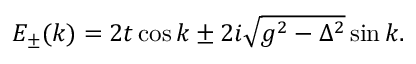<formula> <loc_0><loc_0><loc_500><loc_500>E _ { \pm } ( k ) = 2 t \cos k \pm 2 i \sqrt { g ^ { 2 } - \Delta ^ { 2 } } \sin k .</formula> 